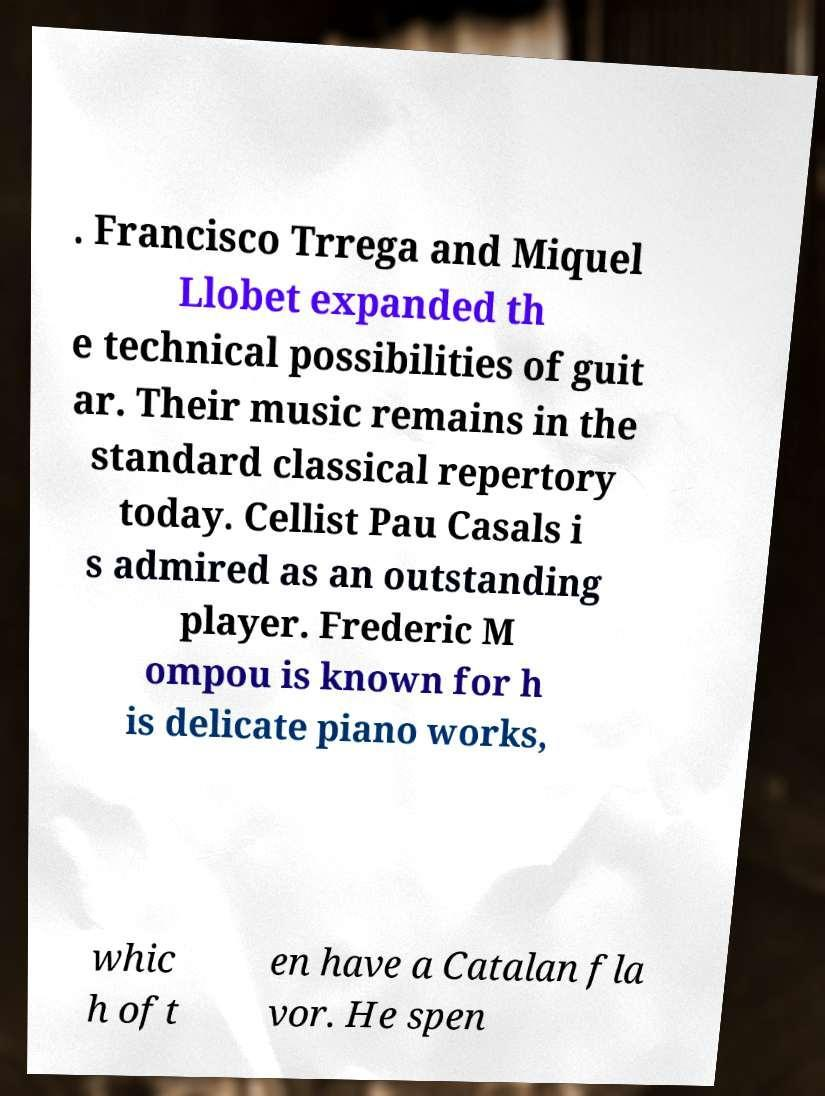Could you extract and type out the text from this image? . Francisco Trrega and Miquel Llobet expanded th e technical possibilities of guit ar. Their music remains in the standard classical repertory today. Cellist Pau Casals i s admired as an outstanding player. Frederic M ompou is known for h is delicate piano works, whic h oft en have a Catalan fla vor. He spen 